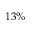<formula> <loc_0><loc_0><loc_500><loc_500>1 3 \%</formula> 